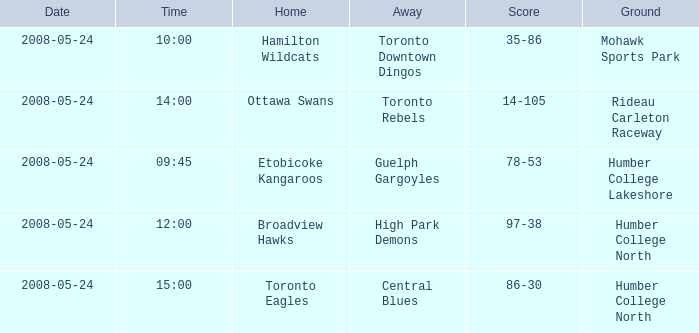I'm looking to parse the entire table for insights. Could you assist me with that? {'header': ['Date', 'Time', 'Home', 'Away', 'Score', 'Ground'], 'rows': [['2008-05-24', '10:00', 'Hamilton Wildcats', 'Toronto Downtown Dingos', '35-86', 'Mohawk Sports Park'], ['2008-05-24', '14:00', 'Ottawa Swans', 'Toronto Rebels', '14-105', 'Rideau Carleton Raceway'], ['2008-05-24', '09:45', 'Etobicoke Kangaroos', 'Guelph Gargoyles', '78-53', 'Humber College Lakeshore'], ['2008-05-24', '12:00', 'Broadview Hawks', 'High Park Demons', '97-38', 'Humber College North'], ['2008-05-24', '15:00', 'Toronto Eagles', 'Central Blues', '86-30', 'Humber College North']]} Who was the home team of the game at the time of 14:00? Ottawa Swans. 